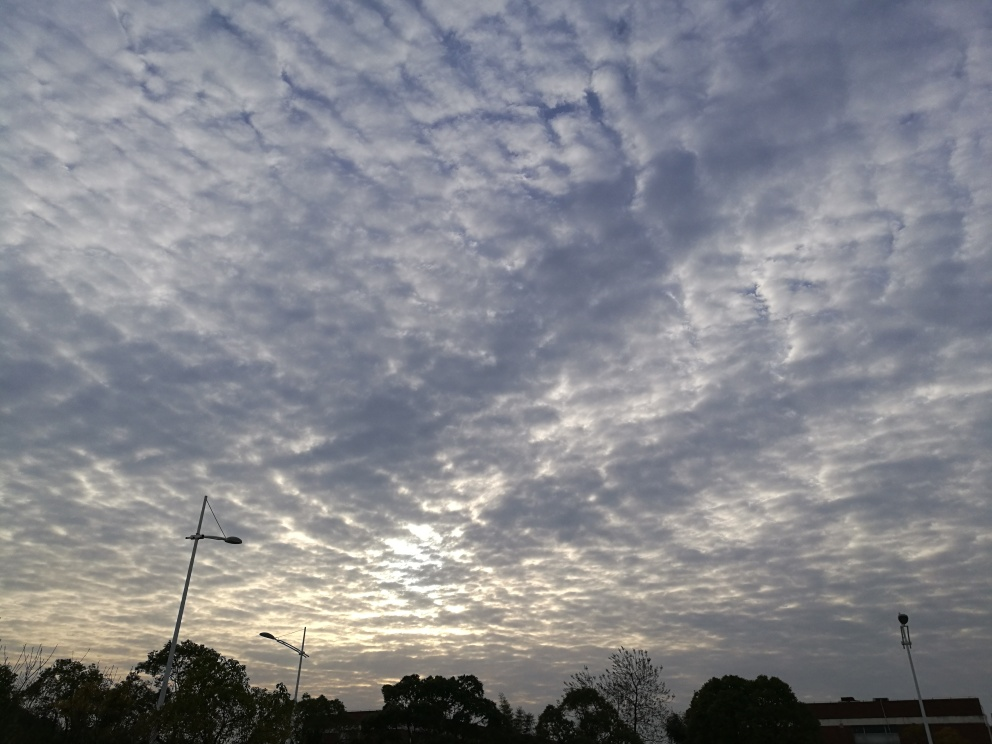What time of day does this image depict? The photo seems to capture either early morning or late afternoon, as suggested by the soft, diffused lighting and the warmer tones near the horizon. The absence of harsh shadows indicates that the sun is not at its peak. 